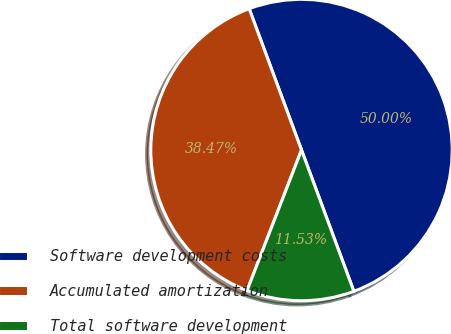Convert chart to OTSL. <chart><loc_0><loc_0><loc_500><loc_500><pie_chart><fcel>Software development costs<fcel>Accumulated amortization<fcel>Total software development<nl><fcel>50.0%<fcel>38.47%<fcel>11.53%<nl></chart> 